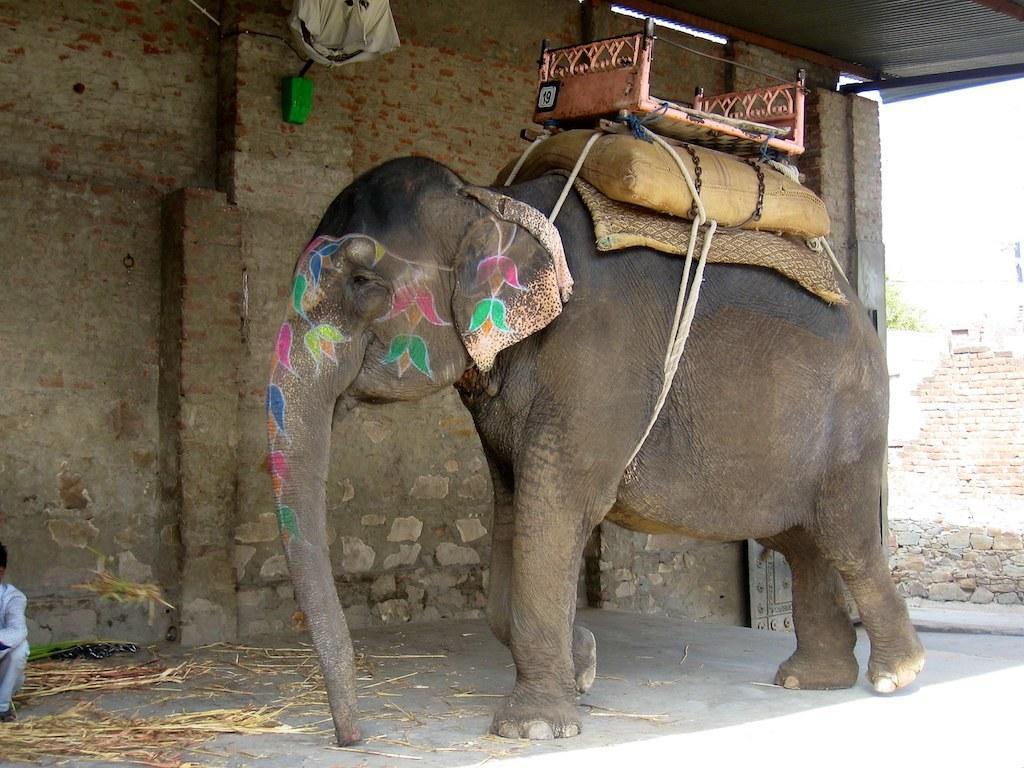Can you describe this image briefly? This is the picture of a place where we have a elephant on which there is a wooden seat like things and some painting on it and to the side there is a brick wall and some other things around. 